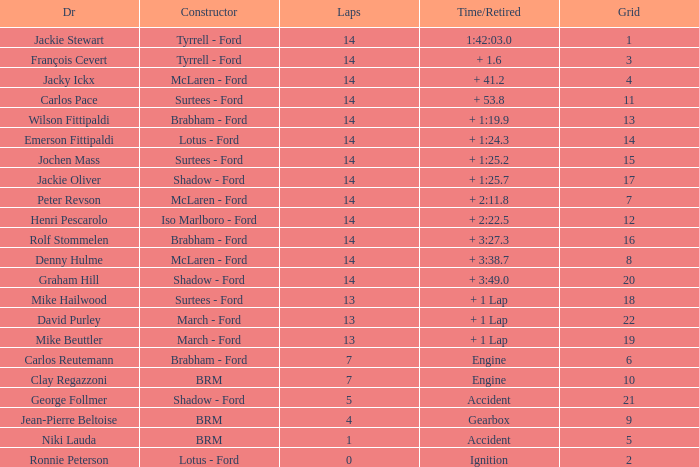What is the low lap total for a grid larger than 16 and has a Time/Retired of + 3:27.3? None. 